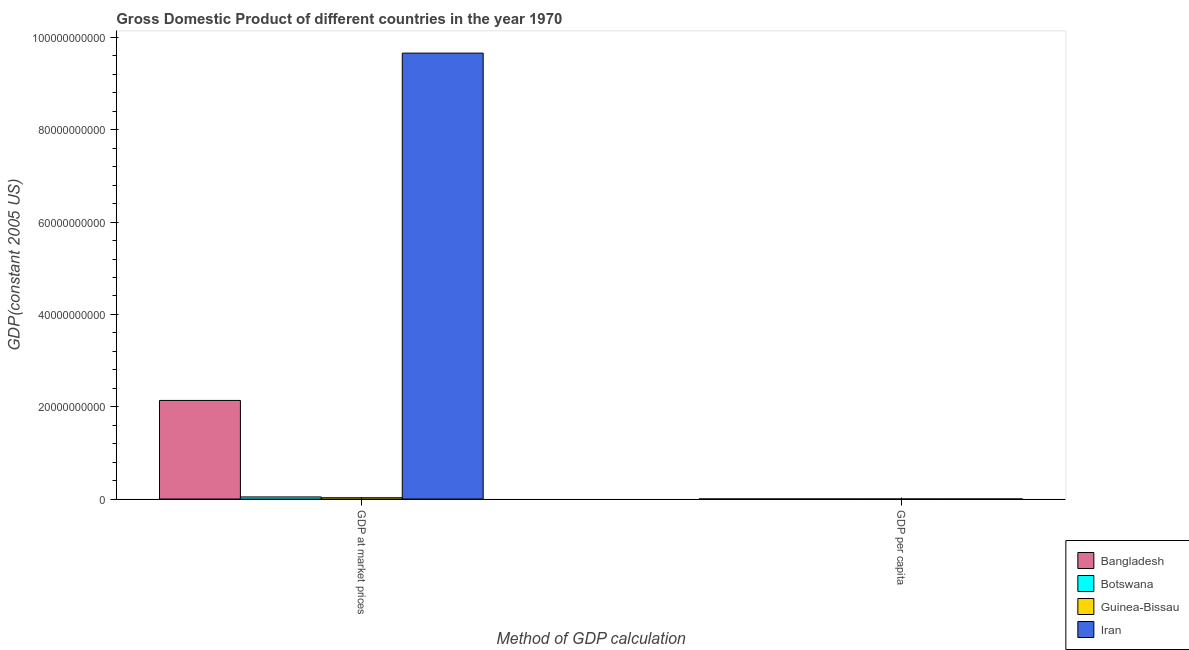How many groups of bars are there?
Your response must be concise. 2. Are the number of bars on each tick of the X-axis equal?
Provide a short and direct response. Yes. How many bars are there on the 2nd tick from the left?
Keep it short and to the point. 4. How many bars are there on the 2nd tick from the right?
Your answer should be very brief. 4. What is the label of the 1st group of bars from the left?
Provide a succinct answer. GDP at market prices. What is the gdp per capita in Guinea-Bissau?
Give a very brief answer. 397.24. Across all countries, what is the maximum gdp at market prices?
Offer a terse response. 9.66e+1. Across all countries, what is the minimum gdp per capita?
Your response must be concise. 328.39. In which country was the gdp at market prices maximum?
Provide a succinct answer. Iran. In which country was the gdp at market prices minimum?
Keep it short and to the point. Guinea-Bissau. What is the total gdp at market prices in the graph?
Offer a very short reply. 1.19e+11. What is the difference between the gdp per capita in Botswana and that in Bangladesh?
Ensure brevity in your answer.  326.56. What is the difference between the gdp per capita in Iran and the gdp at market prices in Botswana?
Your answer should be very brief. -4.54e+08. What is the average gdp at market prices per country?
Make the answer very short. 2.97e+1. What is the difference between the gdp at market prices and gdp per capita in Guinea-Bissau?
Offer a very short reply. 2.83e+08. What is the ratio of the gdp per capita in Botswana to that in Guinea-Bissau?
Your answer should be compact. 1.65. Is the gdp at market prices in Guinea-Bissau less than that in Botswana?
Give a very brief answer. Yes. In how many countries, is the gdp per capita greater than the average gdp per capita taken over all countries?
Offer a very short reply. 1. What does the 2nd bar from the left in GDP at market prices represents?
Make the answer very short. Botswana. What does the 3rd bar from the right in GDP at market prices represents?
Your response must be concise. Botswana. How many bars are there?
Provide a succinct answer. 8. Are all the bars in the graph horizontal?
Your answer should be very brief. No. What is the difference between two consecutive major ticks on the Y-axis?
Offer a very short reply. 2.00e+1. Does the graph contain any zero values?
Ensure brevity in your answer.  No. Does the graph contain grids?
Provide a succinct answer. No. How many legend labels are there?
Make the answer very short. 4. How are the legend labels stacked?
Provide a short and direct response. Vertical. What is the title of the graph?
Offer a terse response. Gross Domestic Product of different countries in the year 1970. What is the label or title of the X-axis?
Make the answer very short. Method of GDP calculation. What is the label or title of the Y-axis?
Ensure brevity in your answer.  GDP(constant 2005 US). What is the GDP(constant 2005 US) in Bangladesh in GDP at market prices?
Your answer should be compact. 2.14e+1. What is the GDP(constant 2005 US) of Botswana in GDP at market prices?
Your answer should be compact. 4.54e+08. What is the GDP(constant 2005 US) of Guinea-Bissau in GDP at market prices?
Your response must be concise. 2.83e+08. What is the GDP(constant 2005 US) in Iran in GDP at market prices?
Offer a very short reply. 9.66e+1. What is the GDP(constant 2005 US) in Bangladesh in GDP per capita?
Provide a succinct answer. 328.39. What is the GDP(constant 2005 US) of Botswana in GDP per capita?
Your answer should be very brief. 654.95. What is the GDP(constant 2005 US) in Guinea-Bissau in GDP per capita?
Give a very brief answer. 397.24. What is the GDP(constant 2005 US) of Iran in GDP per capita?
Your response must be concise. 3387.91. Across all Method of GDP calculation, what is the maximum GDP(constant 2005 US) of Bangladesh?
Provide a succinct answer. 2.14e+1. Across all Method of GDP calculation, what is the maximum GDP(constant 2005 US) in Botswana?
Give a very brief answer. 4.54e+08. Across all Method of GDP calculation, what is the maximum GDP(constant 2005 US) in Guinea-Bissau?
Ensure brevity in your answer.  2.83e+08. Across all Method of GDP calculation, what is the maximum GDP(constant 2005 US) in Iran?
Your answer should be very brief. 9.66e+1. Across all Method of GDP calculation, what is the minimum GDP(constant 2005 US) in Bangladesh?
Keep it short and to the point. 328.39. Across all Method of GDP calculation, what is the minimum GDP(constant 2005 US) in Botswana?
Offer a terse response. 654.95. Across all Method of GDP calculation, what is the minimum GDP(constant 2005 US) of Guinea-Bissau?
Give a very brief answer. 397.24. Across all Method of GDP calculation, what is the minimum GDP(constant 2005 US) of Iran?
Your answer should be very brief. 3387.91. What is the total GDP(constant 2005 US) in Bangladesh in the graph?
Give a very brief answer. 2.14e+1. What is the total GDP(constant 2005 US) in Botswana in the graph?
Your answer should be compact. 4.54e+08. What is the total GDP(constant 2005 US) in Guinea-Bissau in the graph?
Your answer should be compact. 2.83e+08. What is the total GDP(constant 2005 US) in Iran in the graph?
Offer a very short reply. 9.66e+1. What is the difference between the GDP(constant 2005 US) of Bangladesh in GDP at market prices and that in GDP per capita?
Ensure brevity in your answer.  2.14e+1. What is the difference between the GDP(constant 2005 US) in Botswana in GDP at market prices and that in GDP per capita?
Your answer should be compact. 4.54e+08. What is the difference between the GDP(constant 2005 US) in Guinea-Bissau in GDP at market prices and that in GDP per capita?
Make the answer very short. 2.83e+08. What is the difference between the GDP(constant 2005 US) of Iran in GDP at market prices and that in GDP per capita?
Make the answer very short. 9.66e+1. What is the difference between the GDP(constant 2005 US) in Bangladesh in GDP at market prices and the GDP(constant 2005 US) in Botswana in GDP per capita?
Provide a short and direct response. 2.14e+1. What is the difference between the GDP(constant 2005 US) of Bangladesh in GDP at market prices and the GDP(constant 2005 US) of Guinea-Bissau in GDP per capita?
Provide a short and direct response. 2.14e+1. What is the difference between the GDP(constant 2005 US) in Bangladesh in GDP at market prices and the GDP(constant 2005 US) in Iran in GDP per capita?
Make the answer very short. 2.14e+1. What is the difference between the GDP(constant 2005 US) in Botswana in GDP at market prices and the GDP(constant 2005 US) in Guinea-Bissau in GDP per capita?
Offer a very short reply. 4.54e+08. What is the difference between the GDP(constant 2005 US) of Botswana in GDP at market prices and the GDP(constant 2005 US) of Iran in GDP per capita?
Offer a terse response. 4.54e+08. What is the difference between the GDP(constant 2005 US) of Guinea-Bissau in GDP at market prices and the GDP(constant 2005 US) of Iran in GDP per capita?
Offer a terse response. 2.83e+08. What is the average GDP(constant 2005 US) in Bangladesh per Method of GDP calculation?
Keep it short and to the point. 1.07e+1. What is the average GDP(constant 2005 US) in Botswana per Method of GDP calculation?
Provide a succinct answer. 2.27e+08. What is the average GDP(constant 2005 US) in Guinea-Bissau per Method of GDP calculation?
Make the answer very short. 1.41e+08. What is the average GDP(constant 2005 US) in Iran per Method of GDP calculation?
Your answer should be compact. 4.83e+1. What is the difference between the GDP(constant 2005 US) of Bangladesh and GDP(constant 2005 US) of Botswana in GDP at market prices?
Give a very brief answer. 2.09e+1. What is the difference between the GDP(constant 2005 US) of Bangladesh and GDP(constant 2005 US) of Guinea-Bissau in GDP at market prices?
Keep it short and to the point. 2.11e+1. What is the difference between the GDP(constant 2005 US) of Bangladesh and GDP(constant 2005 US) of Iran in GDP at market prices?
Make the answer very short. -7.52e+1. What is the difference between the GDP(constant 2005 US) of Botswana and GDP(constant 2005 US) of Guinea-Bissau in GDP at market prices?
Give a very brief answer. 1.71e+08. What is the difference between the GDP(constant 2005 US) in Botswana and GDP(constant 2005 US) in Iran in GDP at market prices?
Offer a very short reply. -9.61e+1. What is the difference between the GDP(constant 2005 US) of Guinea-Bissau and GDP(constant 2005 US) of Iran in GDP at market prices?
Keep it short and to the point. -9.63e+1. What is the difference between the GDP(constant 2005 US) in Bangladesh and GDP(constant 2005 US) in Botswana in GDP per capita?
Your answer should be very brief. -326.56. What is the difference between the GDP(constant 2005 US) of Bangladesh and GDP(constant 2005 US) of Guinea-Bissau in GDP per capita?
Offer a very short reply. -68.85. What is the difference between the GDP(constant 2005 US) of Bangladesh and GDP(constant 2005 US) of Iran in GDP per capita?
Offer a terse response. -3059.52. What is the difference between the GDP(constant 2005 US) of Botswana and GDP(constant 2005 US) of Guinea-Bissau in GDP per capita?
Your answer should be compact. 257.71. What is the difference between the GDP(constant 2005 US) in Botswana and GDP(constant 2005 US) in Iran in GDP per capita?
Make the answer very short. -2732.95. What is the difference between the GDP(constant 2005 US) in Guinea-Bissau and GDP(constant 2005 US) in Iran in GDP per capita?
Your answer should be compact. -2990.66. What is the ratio of the GDP(constant 2005 US) of Bangladesh in GDP at market prices to that in GDP per capita?
Your answer should be compact. 6.50e+07. What is the ratio of the GDP(constant 2005 US) of Botswana in GDP at market prices to that in GDP per capita?
Ensure brevity in your answer.  6.93e+05. What is the ratio of the GDP(constant 2005 US) in Guinea-Bissau in GDP at market prices to that in GDP per capita?
Your answer should be very brief. 7.12e+05. What is the ratio of the GDP(constant 2005 US) in Iran in GDP at market prices to that in GDP per capita?
Provide a short and direct response. 2.85e+07. What is the difference between the highest and the second highest GDP(constant 2005 US) in Bangladesh?
Offer a very short reply. 2.14e+1. What is the difference between the highest and the second highest GDP(constant 2005 US) of Botswana?
Your response must be concise. 4.54e+08. What is the difference between the highest and the second highest GDP(constant 2005 US) of Guinea-Bissau?
Ensure brevity in your answer.  2.83e+08. What is the difference between the highest and the second highest GDP(constant 2005 US) in Iran?
Keep it short and to the point. 9.66e+1. What is the difference between the highest and the lowest GDP(constant 2005 US) in Bangladesh?
Keep it short and to the point. 2.14e+1. What is the difference between the highest and the lowest GDP(constant 2005 US) of Botswana?
Your answer should be very brief. 4.54e+08. What is the difference between the highest and the lowest GDP(constant 2005 US) in Guinea-Bissau?
Your answer should be very brief. 2.83e+08. What is the difference between the highest and the lowest GDP(constant 2005 US) in Iran?
Offer a very short reply. 9.66e+1. 